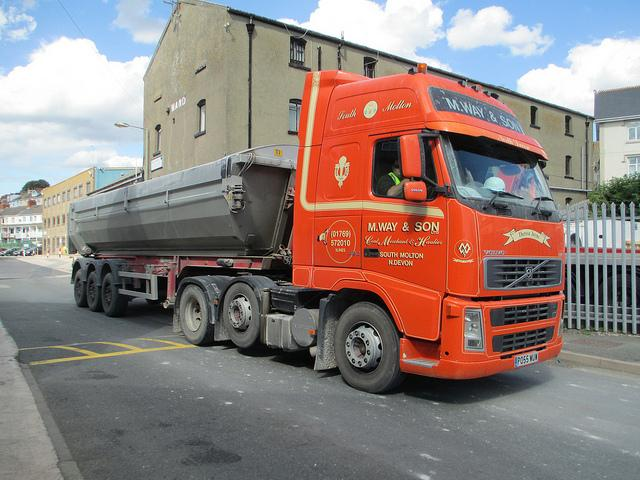What business park does this company operate out of? south molten 